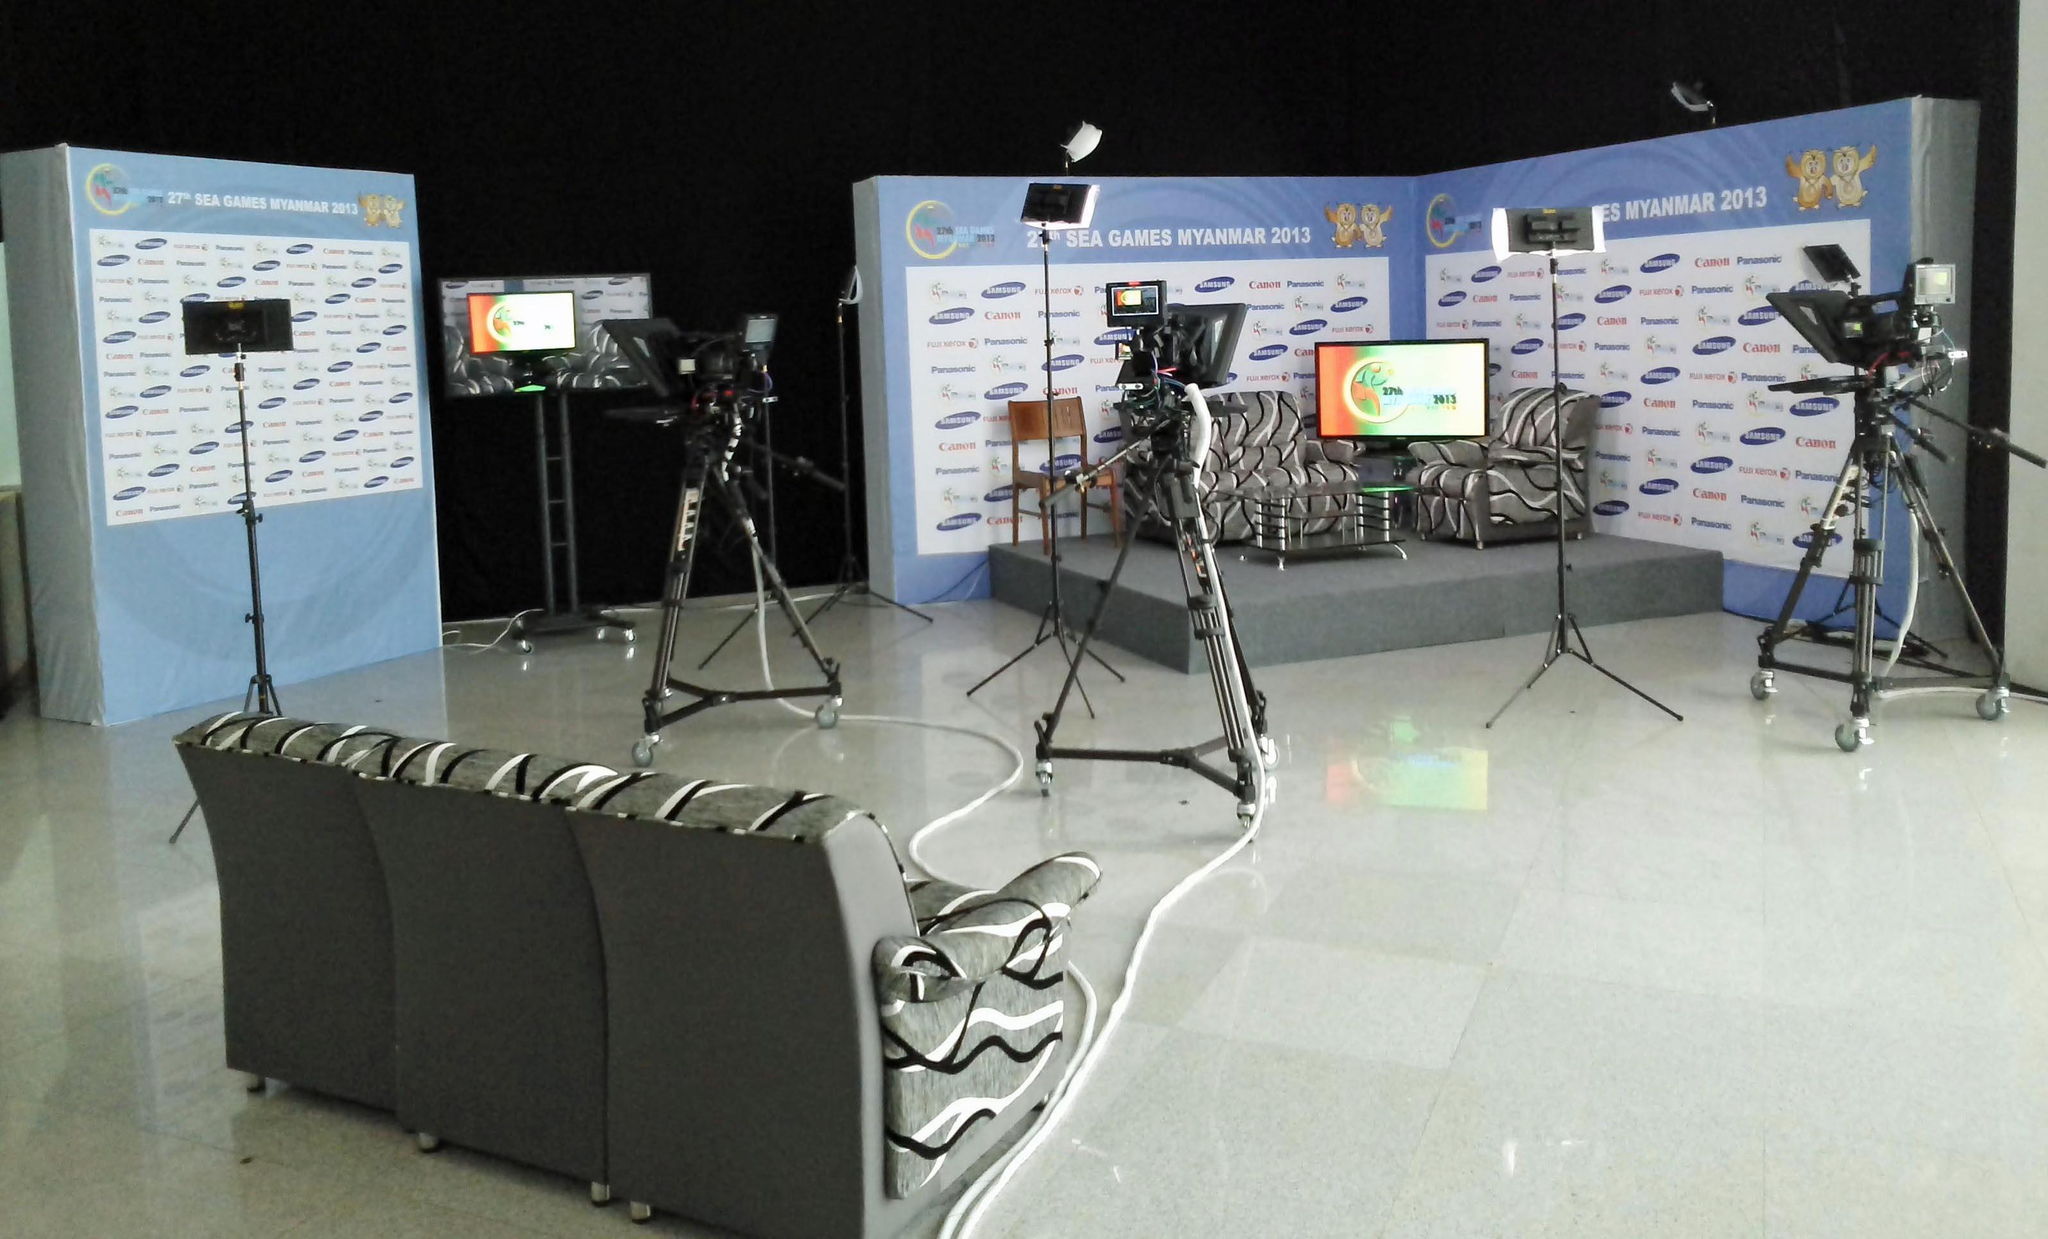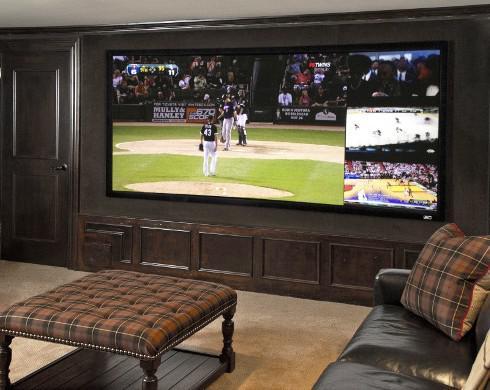The first image is the image on the left, the second image is the image on the right. For the images shown, is this caption "In at least one of the images, humans are present, probably discussing how best to deliver the news." true? Answer yes or no. No. The first image is the image on the left, the second image is the image on the right. Assess this claim about the two images: "At least one image includes people facing large screens in front of them.". Correct or not? Answer yes or no. No. 